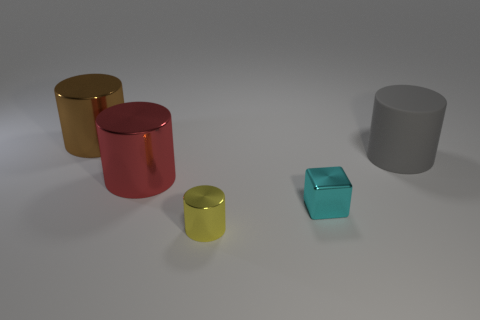Are there any other things that have the same material as the large gray cylinder?
Provide a succinct answer. No. Are there fewer large red cylinders than big green things?
Your response must be concise. No. There is a small thing that is the same shape as the large brown object; what is its material?
Keep it short and to the point. Metal. Is the number of cyan things greater than the number of tiny blue matte cubes?
Your answer should be compact. Yes. How many other things are there of the same color as the matte object?
Provide a short and direct response. 0. Do the tiny cyan block and the small thing in front of the tiny cyan metallic cube have the same material?
Offer a terse response. Yes. What number of large gray rubber cylinders are in front of the cylinder that is in front of the large shiny object in front of the brown metal object?
Your response must be concise. 0. Is the number of brown metal things that are to the right of the tiny cyan shiny cube less than the number of large matte cylinders that are left of the large red metallic cylinder?
Offer a very short reply. No. How many other objects are there of the same material as the small cylinder?
Offer a terse response. 3. There is a gray cylinder that is the same size as the brown metal cylinder; what material is it?
Your answer should be compact. Rubber. 